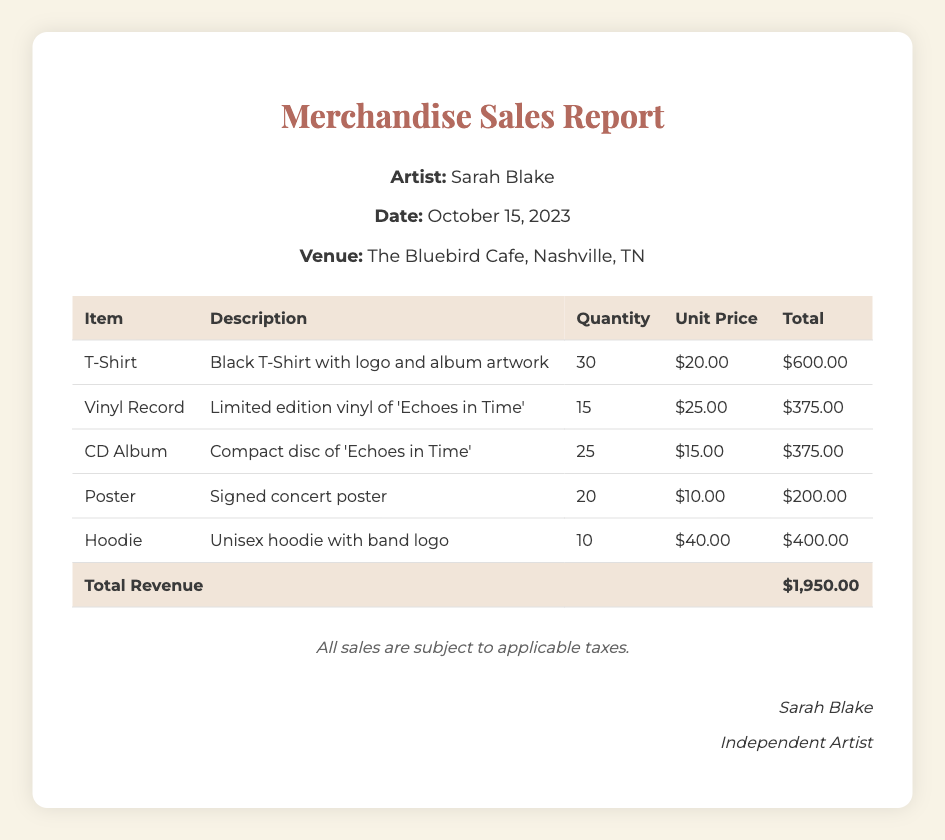What is the artist's name? The artist's name is stated at the top of the document under the title and in the concert details section.
Answer: Sarah Blake What is the date of the concert? The concert date is mentioned in the concert details section of the document.
Answer: October 15, 2023 What is the venue for the concert? The venue is listed in the concert details part of the document.
Answer: The Bluebird Cafe, Nashville, TN How many T-Shirts were sold? The quantity of T-Shirts sold is provided in the itemized sales table.
Answer: 30 What is the unit price of the Vinyl Record? The unit price of the Vinyl Record can be found in the itemized sales table under "Unit Price."
Answer: $25.00 What is the total revenue generated from merchandise sales? The total revenue is summarized at the bottom of the itemized sales table as the total revenue line.
Answer: $1,950.00 Which item had the highest unit price? The item with the highest unit price is determined by comparing all unit prices listed in the table.
Answer: Hoodie What is the description of the CD Album? The description is located in the itemized sales table next to the CD Album item.
Answer: Compact disc of 'Echoes in Time' How many total items were sold? The total number of items can be calculated by summing the quantities of all listed merchandise.
Answer: 110 